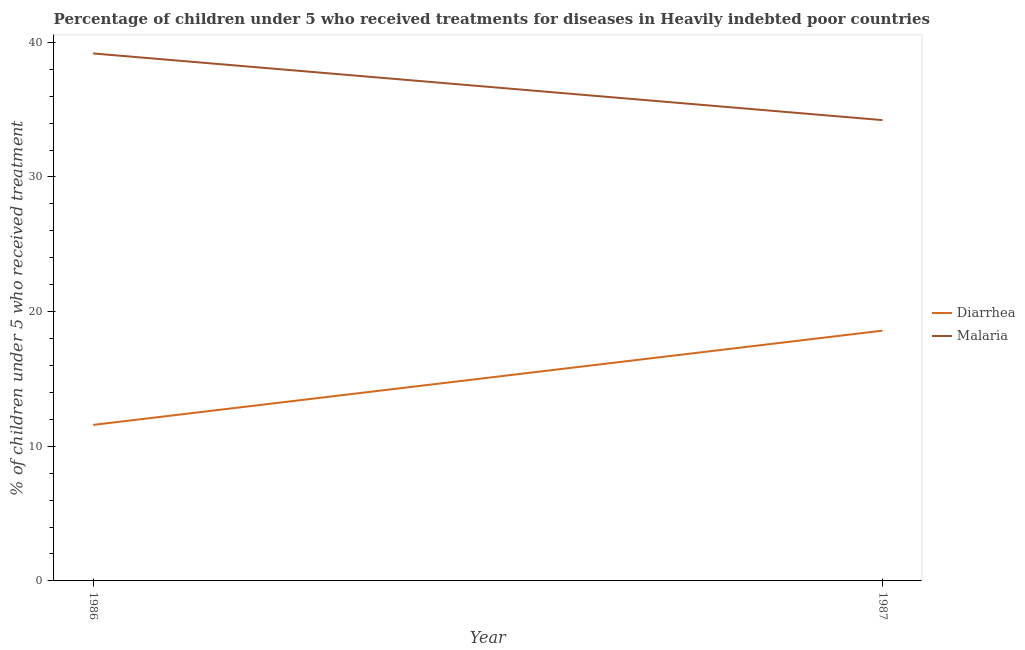How many different coloured lines are there?
Provide a short and direct response. 2. Does the line corresponding to percentage of children who received treatment for diarrhoea intersect with the line corresponding to percentage of children who received treatment for malaria?
Ensure brevity in your answer.  No. Is the number of lines equal to the number of legend labels?
Give a very brief answer. Yes. What is the percentage of children who received treatment for malaria in 1987?
Offer a terse response. 34.22. Across all years, what is the maximum percentage of children who received treatment for malaria?
Provide a succinct answer. 39.18. Across all years, what is the minimum percentage of children who received treatment for diarrhoea?
Provide a short and direct response. 11.59. What is the total percentage of children who received treatment for diarrhoea in the graph?
Your response must be concise. 30.17. What is the difference between the percentage of children who received treatment for diarrhoea in 1986 and that in 1987?
Ensure brevity in your answer.  -7. What is the difference between the percentage of children who received treatment for diarrhoea in 1986 and the percentage of children who received treatment for malaria in 1987?
Provide a succinct answer. -22.64. What is the average percentage of children who received treatment for diarrhoea per year?
Give a very brief answer. 15.09. In the year 1987, what is the difference between the percentage of children who received treatment for diarrhoea and percentage of children who received treatment for malaria?
Offer a very short reply. -15.64. In how many years, is the percentage of children who received treatment for malaria greater than 36 %?
Ensure brevity in your answer.  1. What is the ratio of the percentage of children who received treatment for malaria in 1986 to that in 1987?
Your answer should be very brief. 1.14. Is the percentage of children who received treatment for diarrhoea in 1986 less than that in 1987?
Offer a very short reply. Yes. In how many years, is the percentage of children who received treatment for malaria greater than the average percentage of children who received treatment for malaria taken over all years?
Your answer should be very brief. 1. How many lines are there?
Ensure brevity in your answer.  2. How many years are there in the graph?
Provide a succinct answer. 2. What is the difference between two consecutive major ticks on the Y-axis?
Your response must be concise. 10. Are the values on the major ticks of Y-axis written in scientific E-notation?
Offer a terse response. No. Does the graph contain any zero values?
Ensure brevity in your answer.  No. Where does the legend appear in the graph?
Offer a terse response. Center right. How are the legend labels stacked?
Make the answer very short. Vertical. What is the title of the graph?
Provide a succinct answer. Percentage of children under 5 who received treatments for diseases in Heavily indebted poor countries. What is the label or title of the Y-axis?
Keep it short and to the point. % of children under 5 who received treatment. What is the % of children under 5 who received treatment of Diarrhea in 1986?
Provide a succinct answer. 11.59. What is the % of children under 5 who received treatment of Malaria in 1986?
Keep it short and to the point. 39.18. What is the % of children under 5 who received treatment of Diarrhea in 1987?
Keep it short and to the point. 18.59. What is the % of children under 5 who received treatment of Malaria in 1987?
Your response must be concise. 34.22. Across all years, what is the maximum % of children under 5 who received treatment in Diarrhea?
Make the answer very short. 18.59. Across all years, what is the maximum % of children under 5 who received treatment in Malaria?
Offer a very short reply. 39.18. Across all years, what is the minimum % of children under 5 who received treatment of Diarrhea?
Make the answer very short. 11.59. Across all years, what is the minimum % of children under 5 who received treatment of Malaria?
Provide a succinct answer. 34.22. What is the total % of children under 5 who received treatment of Diarrhea in the graph?
Your answer should be compact. 30.17. What is the total % of children under 5 who received treatment of Malaria in the graph?
Give a very brief answer. 73.4. What is the difference between the % of children under 5 who received treatment in Diarrhea in 1986 and that in 1987?
Your answer should be very brief. -7. What is the difference between the % of children under 5 who received treatment of Malaria in 1986 and that in 1987?
Your answer should be very brief. 4.95. What is the difference between the % of children under 5 who received treatment in Diarrhea in 1986 and the % of children under 5 who received treatment in Malaria in 1987?
Your answer should be very brief. -22.64. What is the average % of children under 5 who received treatment in Diarrhea per year?
Your answer should be very brief. 15.09. What is the average % of children under 5 who received treatment in Malaria per year?
Offer a very short reply. 36.7. In the year 1986, what is the difference between the % of children under 5 who received treatment of Diarrhea and % of children under 5 who received treatment of Malaria?
Provide a short and direct response. -27.59. In the year 1987, what is the difference between the % of children under 5 who received treatment in Diarrhea and % of children under 5 who received treatment in Malaria?
Your answer should be compact. -15.64. What is the ratio of the % of children under 5 who received treatment of Diarrhea in 1986 to that in 1987?
Your answer should be very brief. 0.62. What is the ratio of the % of children under 5 who received treatment of Malaria in 1986 to that in 1987?
Offer a very short reply. 1.14. What is the difference between the highest and the second highest % of children under 5 who received treatment of Diarrhea?
Provide a succinct answer. 7. What is the difference between the highest and the second highest % of children under 5 who received treatment of Malaria?
Offer a very short reply. 4.95. What is the difference between the highest and the lowest % of children under 5 who received treatment of Diarrhea?
Give a very brief answer. 7. What is the difference between the highest and the lowest % of children under 5 who received treatment of Malaria?
Offer a terse response. 4.95. 